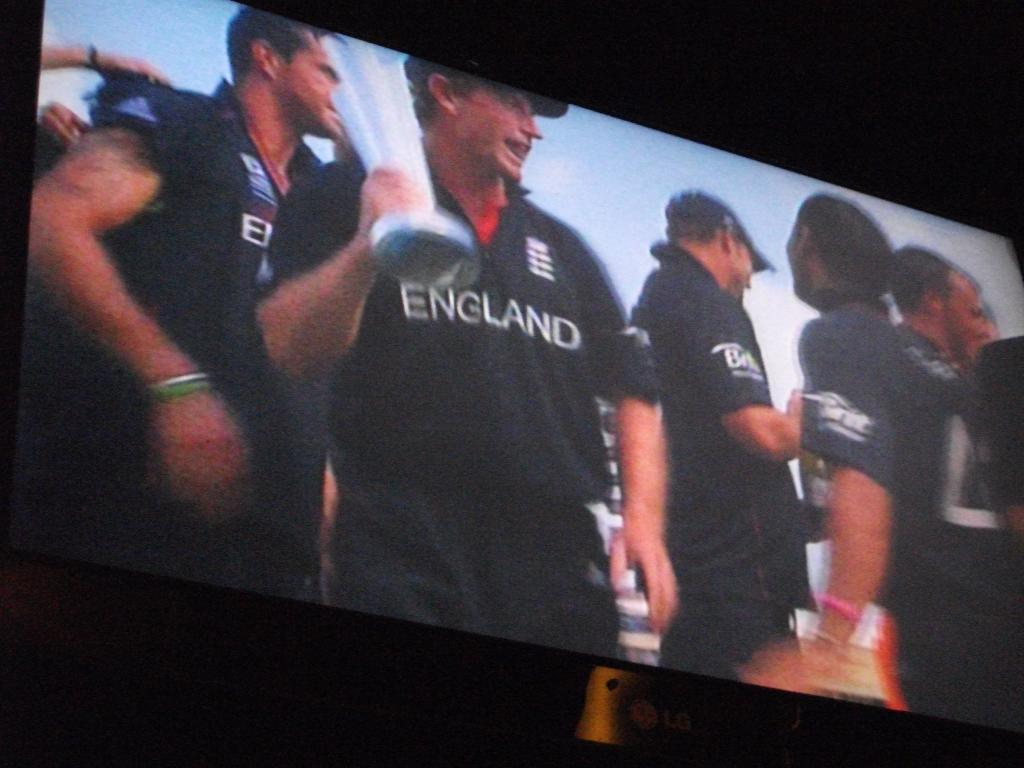<image>
Offer a succinct explanation of the picture presented. A sports team from England is holding up their winning trophy. 